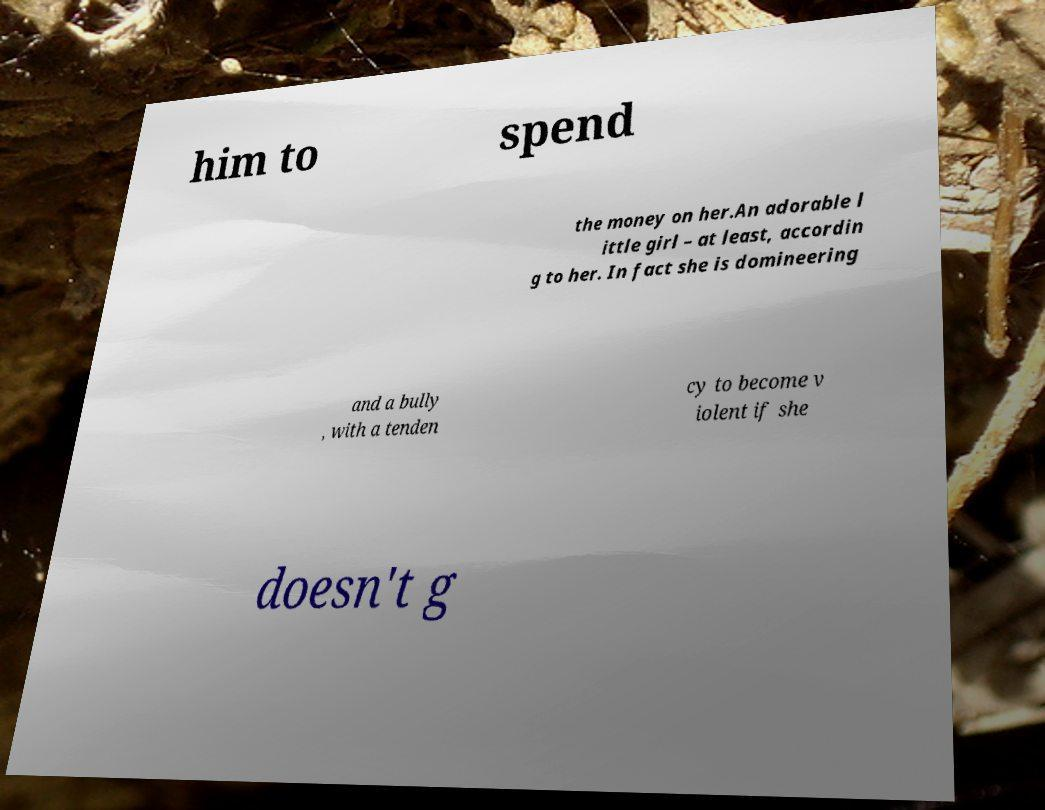I need the written content from this picture converted into text. Can you do that? him to spend the money on her.An adorable l ittle girl – at least, accordin g to her. In fact she is domineering and a bully , with a tenden cy to become v iolent if she doesn't g 